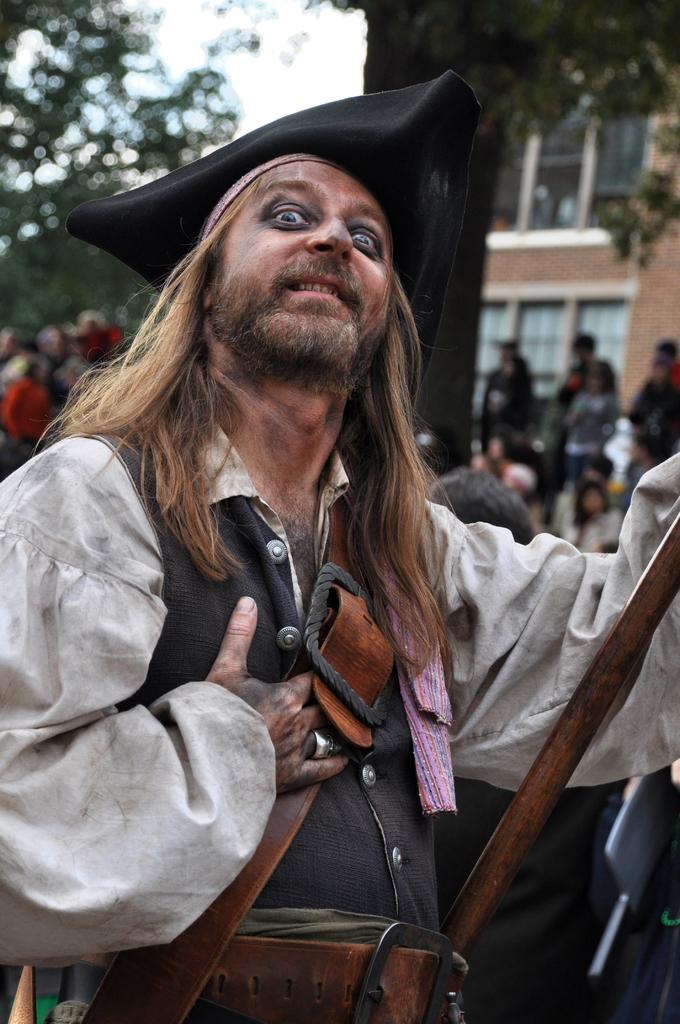What is the man in the image wearing? The man in the image is wearing a costume. What can be seen in the background of the image? There are blurred people, trees, a building, and the sky visible in the background of the image. What type of oatmeal is being served in the image? There is no oatmeal present in the image. How many bits of destruction can be seen in the image? There is no destruction present in the image. 